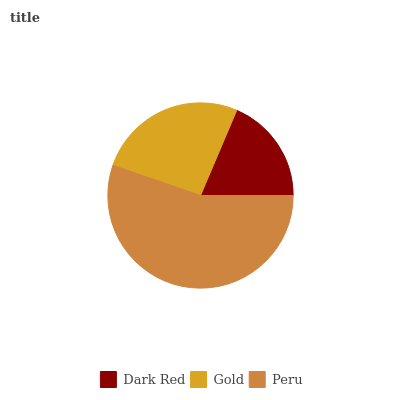Is Dark Red the minimum?
Answer yes or no. Yes. Is Peru the maximum?
Answer yes or no. Yes. Is Gold the minimum?
Answer yes or no. No. Is Gold the maximum?
Answer yes or no. No. Is Gold greater than Dark Red?
Answer yes or no. Yes. Is Dark Red less than Gold?
Answer yes or no. Yes. Is Dark Red greater than Gold?
Answer yes or no. No. Is Gold less than Dark Red?
Answer yes or no. No. Is Gold the high median?
Answer yes or no. Yes. Is Gold the low median?
Answer yes or no. Yes. Is Peru the high median?
Answer yes or no. No. Is Peru the low median?
Answer yes or no. No. 